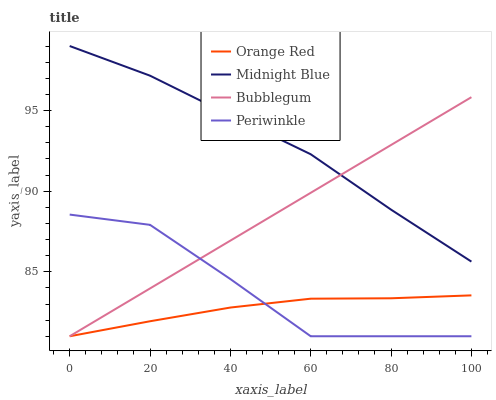Does Orange Red have the minimum area under the curve?
Answer yes or no. Yes. Does Midnight Blue have the maximum area under the curve?
Answer yes or no. Yes. Does Bubblegum have the minimum area under the curve?
Answer yes or no. No. Does Bubblegum have the maximum area under the curve?
Answer yes or no. No. Is Bubblegum the smoothest?
Answer yes or no. Yes. Is Periwinkle the roughest?
Answer yes or no. Yes. Is Orange Red the smoothest?
Answer yes or no. No. Is Orange Red the roughest?
Answer yes or no. No. Does Midnight Blue have the lowest value?
Answer yes or no. No. Does Midnight Blue have the highest value?
Answer yes or no. Yes. Does Bubblegum have the highest value?
Answer yes or no. No. Is Periwinkle less than Midnight Blue?
Answer yes or no. Yes. Is Midnight Blue greater than Orange Red?
Answer yes or no. Yes. Does Periwinkle intersect Bubblegum?
Answer yes or no. Yes. Is Periwinkle less than Bubblegum?
Answer yes or no. No. Is Periwinkle greater than Bubblegum?
Answer yes or no. No. Does Periwinkle intersect Midnight Blue?
Answer yes or no. No. 